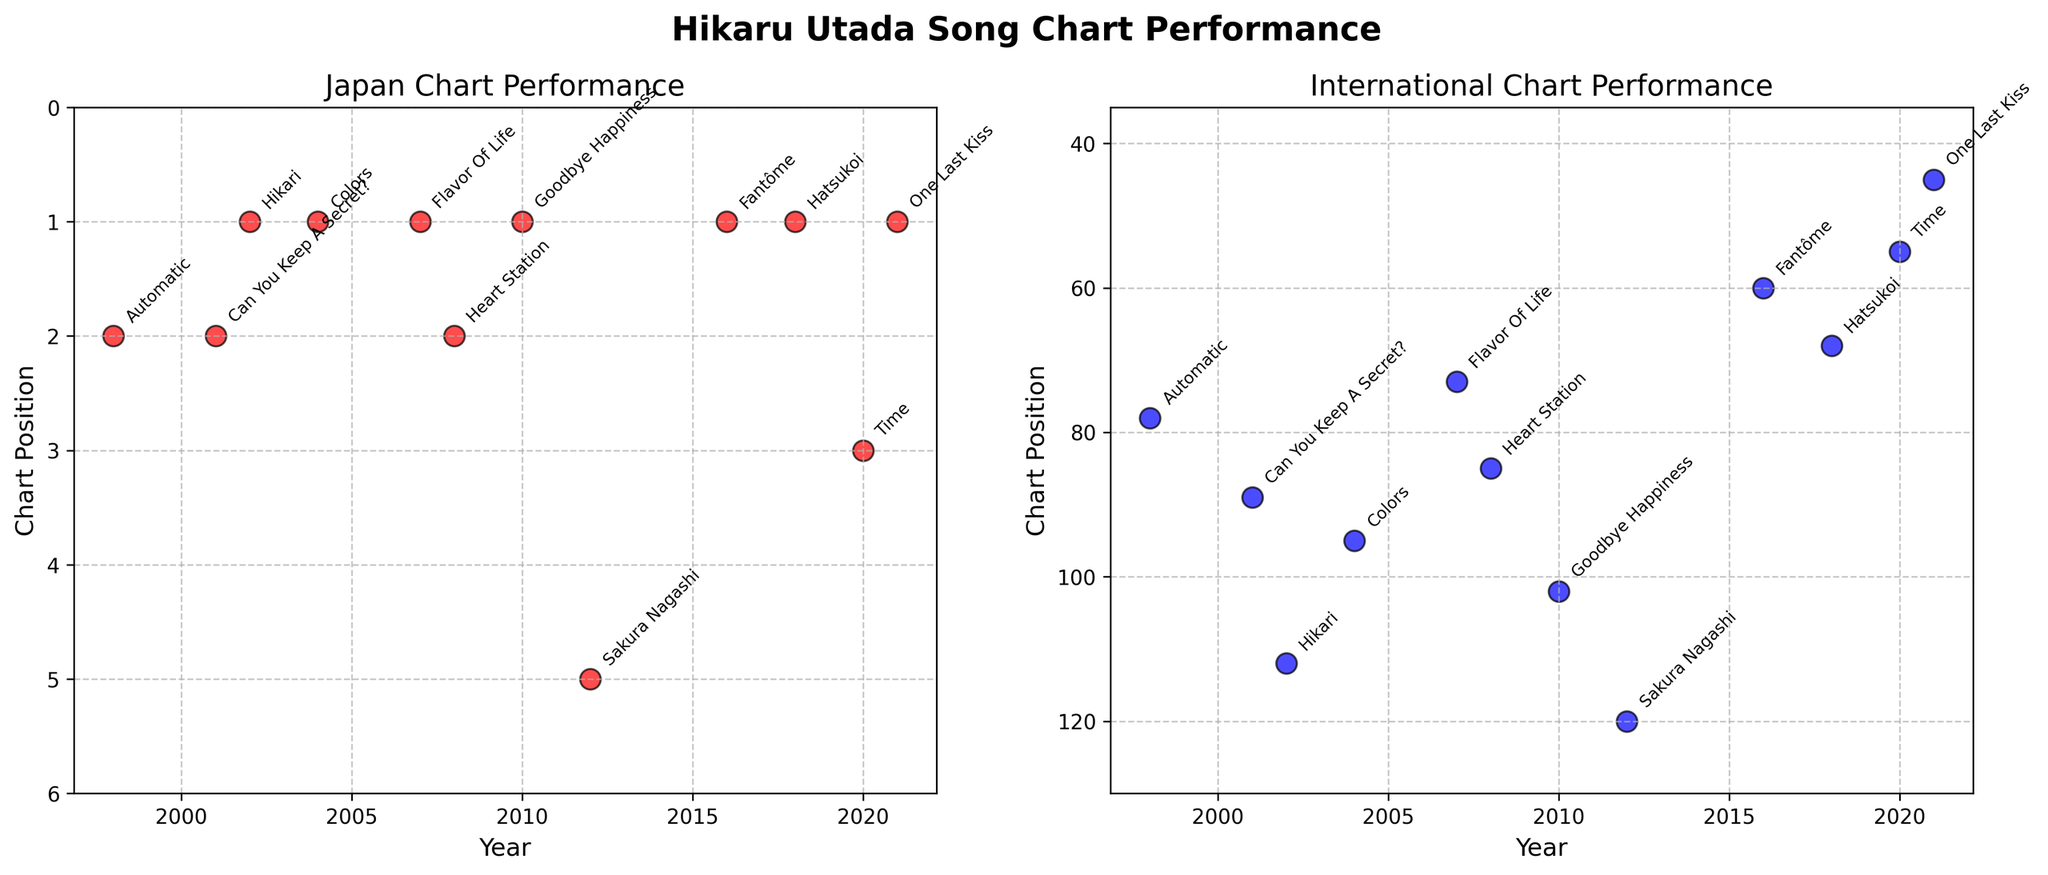What is the highest chart position achieved by Hikaru Utada’s song in Japan? Look for the lowest numerical value in the Japan Chart Performance subplot since lower chart positions represent higher rankings. The song "Hikari" in 2002 achieved the No. 1 position which is the highest.
Answer: 1 Which year had the best international chart performance for Hikaru Utada's songs? Look for the smallest number in the International Chart Performance subplot since lower chart positions are better. The song "One Last Kiss" in 2021 had the best international chart performance at position 45.
Answer: 2021 How many songs reached the No. 1 position on Japan's chart? Count the number of data points in the Japan subplot where the chart position is 1. The songs are "Hikari" (2002), "Colors" (2004), "Flavor of Life" (2007), "Goodbye Happiness" (2010), "Fantôme" (2016), "Hatsukoi" (2018), and "One Last Kiss" (2021). There are 7 songs in total.
Answer: 7 What is the difference in international chart positions for the best and worst performing songs? Identify the position of the best performing song "One Last Kiss" (2021) at position 45 and the worst performing song "Sakura Nagashi" (2012) at position 120. Calculate the difference: 120 - 45 = 75.
Answer: 75 Between which years did Hikaru Utada release songs most frequently? Observe the gaps between years in the x-axis for both subplots. Notice the shortest interval or the smallest difference between consecutive years. "Automatic" (1998) and "Can You Keep A Secret?" (2001) have a 3-year gap, which is one of the smallest intervals until 2020-2021 where there is a single year difference between "Time" (2020) and "One Last Kiss" (2021).
Answer: 2020-2021 Which song performed better on the international chart in the same year two songs were released? Look for years with multiple songs and compare their international chart positions. However, no such occurrences are in the data. All the songs were released in separate years.
Answer: No year had multiple song releases In general, is there a pattern in the gap between Japan and international chart positions? Compare the Japan and international positions for each song. Notice most songs have Japan chart positions significantly smaller (better) than international, indicating they chart higher in Japan consistently.
Answer: Japan positions generally better Which year had the worst performance in the Japanese chart? Look for the highest numerical value in the Japan Chart Performance subplot since higher numbers indicate lower ranking positions. "Sakura Nagashi" in 2012 reached position 5 which is the worst performance.
Answer: 2012 How does the year "Time" (2020) compare to other years in terms of international chart performance? Find the international chart position of "Time" (2020) in the International Chart Performance subplot; it's 55. Compare it to other data points, noting it's better than the majority but not the best. It is the second-best after "One Last Kiss" (2021).
Answer: The second-best international performance Did any song reach the same peak chart position in both Japan and international markets? Check both subplots for any song with the same numerical chart position in Japan and International charts. No song has the same ranking position in both Japan and international markets.
Answer: No 